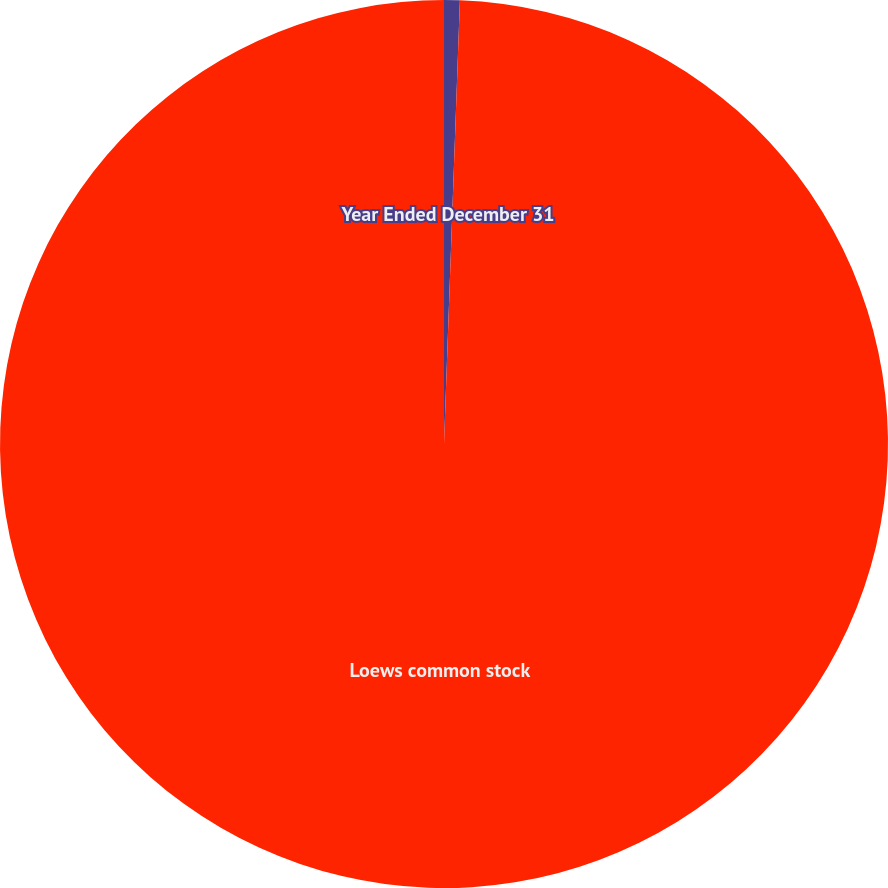Convert chart to OTSL. <chart><loc_0><loc_0><loc_500><loc_500><pie_chart><fcel>Year Ended December 31<fcel>Loews common stock<nl><fcel>0.57%<fcel>99.43%<nl></chart> 